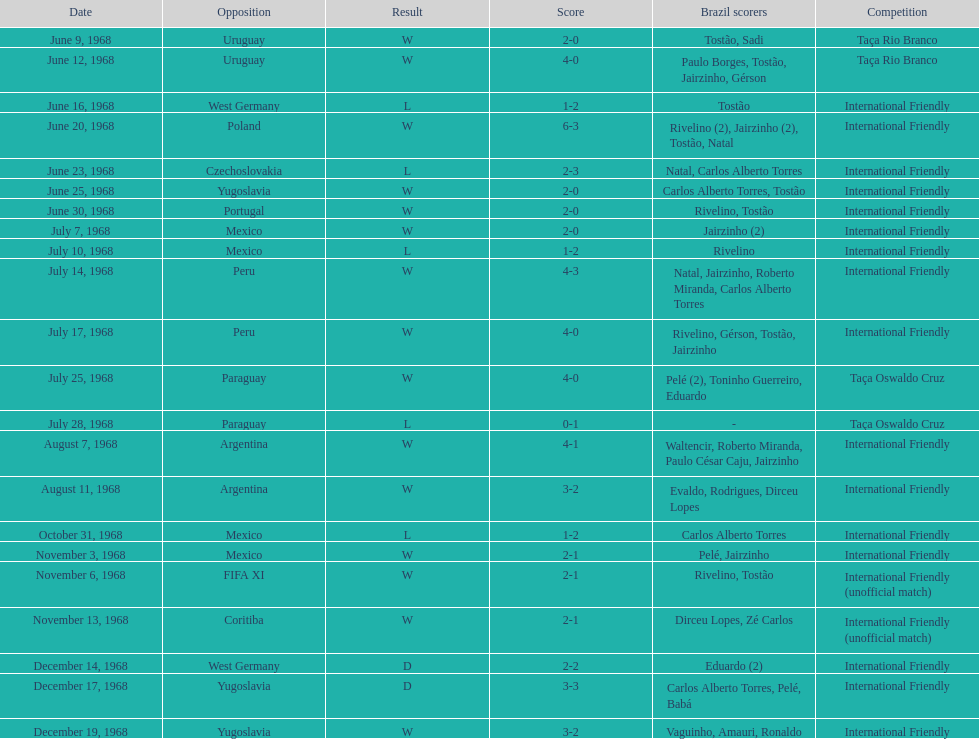Total number of wins 15. Parse the full table. {'header': ['Date', 'Opposition', 'Result', 'Score', 'Brazil scorers', 'Competition'], 'rows': [['June 9, 1968', 'Uruguay', 'W', '2-0', 'Tostão, Sadi', 'Taça Rio Branco'], ['June 12, 1968', 'Uruguay', 'W', '4-0', 'Paulo Borges, Tostão, Jairzinho, Gérson', 'Taça Rio Branco'], ['June 16, 1968', 'West Germany', 'L', '1-2', 'Tostão', 'International Friendly'], ['June 20, 1968', 'Poland', 'W', '6-3', 'Rivelino (2), Jairzinho (2), Tostão, Natal', 'International Friendly'], ['June 23, 1968', 'Czechoslovakia', 'L', '2-3', 'Natal, Carlos Alberto Torres', 'International Friendly'], ['June 25, 1968', 'Yugoslavia', 'W', '2-0', 'Carlos Alberto Torres, Tostão', 'International Friendly'], ['June 30, 1968', 'Portugal', 'W', '2-0', 'Rivelino, Tostão', 'International Friendly'], ['July 7, 1968', 'Mexico', 'W', '2-0', 'Jairzinho (2)', 'International Friendly'], ['July 10, 1968', 'Mexico', 'L', '1-2', 'Rivelino', 'International Friendly'], ['July 14, 1968', 'Peru', 'W', '4-3', 'Natal, Jairzinho, Roberto Miranda, Carlos Alberto Torres', 'International Friendly'], ['July 17, 1968', 'Peru', 'W', '4-0', 'Rivelino, Gérson, Tostão, Jairzinho', 'International Friendly'], ['July 25, 1968', 'Paraguay', 'W', '4-0', 'Pelé (2), Toninho Guerreiro, Eduardo', 'Taça Oswaldo Cruz'], ['July 28, 1968', 'Paraguay', 'L', '0-1', '-', 'Taça Oswaldo Cruz'], ['August 7, 1968', 'Argentina', 'W', '4-1', 'Waltencir, Roberto Miranda, Paulo César Caju, Jairzinho', 'International Friendly'], ['August 11, 1968', 'Argentina', 'W', '3-2', 'Evaldo, Rodrigues, Dirceu Lopes', 'International Friendly'], ['October 31, 1968', 'Mexico', 'L', '1-2', 'Carlos Alberto Torres', 'International Friendly'], ['November 3, 1968', 'Mexico', 'W', '2-1', 'Pelé, Jairzinho', 'International Friendly'], ['November 6, 1968', 'FIFA XI', 'W', '2-1', 'Rivelino, Tostão', 'International Friendly (unofficial match)'], ['November 13, 1968', 'Coritiba', 'W', '2-1', 'Dirceu Lopes, Zé Carlos', 'International Friendly (unofficial match)'], ['December 14, 1968', 'West Germany', 'D', '2-2', 'Eduardo (2)', 'International Friendly'], ['December 17, 1968', 'Yugoslavia', 'D', '3-3', 'Carlos Alberto Torres, Pelé, Babá', 'International Friendly'], ['December 19, 1968', 'Yugoslavia', 'W', '3-2', 'Vaguinho, Amauri, Ronaldo', 'International Friendly']]} 